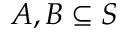<formula> <loc_0><loc_0><loc_500><loc_500>A , B \subseteq S</formula> 